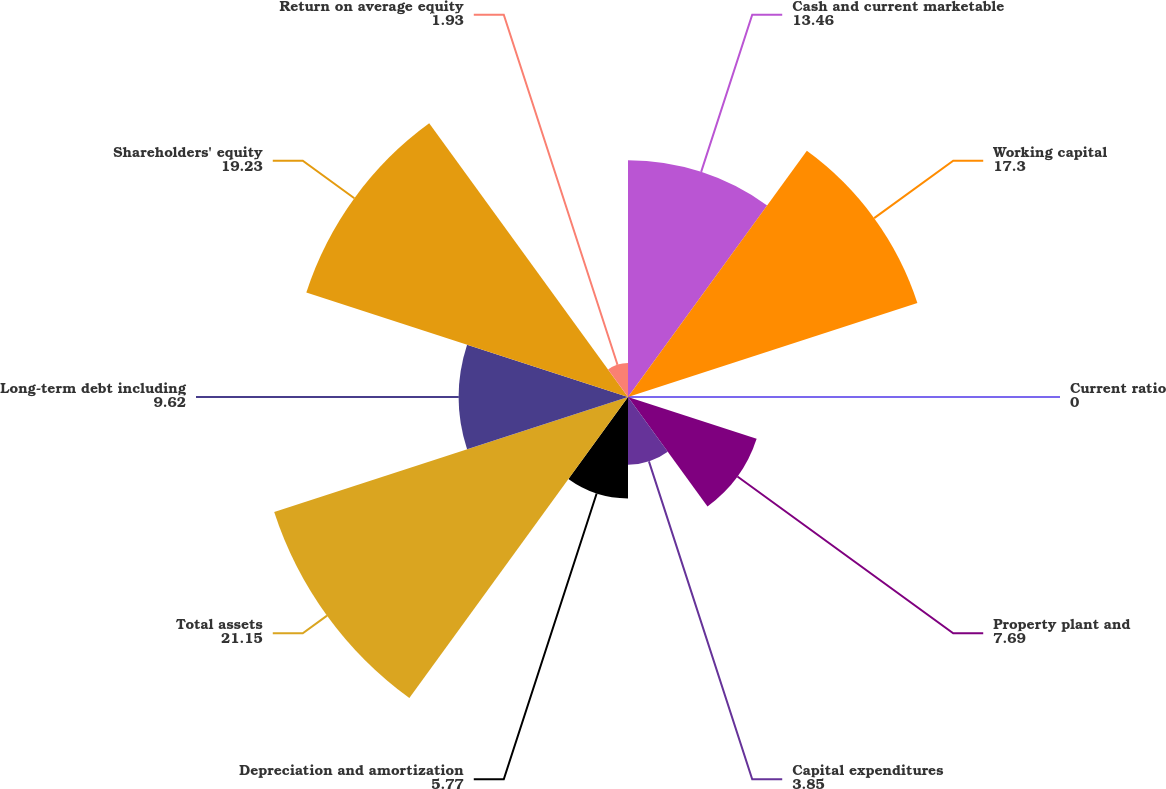<chart> <loc_0><loc_0><loc_500><loc_500><pie_chart><fcel>Cash and current marketable<fcel>Working capital<fcel>Current ratio<fcel>Property plant and<fcel>Capital expenditures<fcel>Depreciation and amortization<fcel>Total assets<fcel>Long-term debt including<fcel>Shareholders' equity<fcel>Return on average equity<nl><fcel>13.46%<fcel>17.3%<fcel>0.0%<fcel>7.69%<fcel>3.85%<fcel>5.77%<fcel>21.15%<fcel>9.62%<fcel>19.23%<fcel>1.93%<nl></chart> 